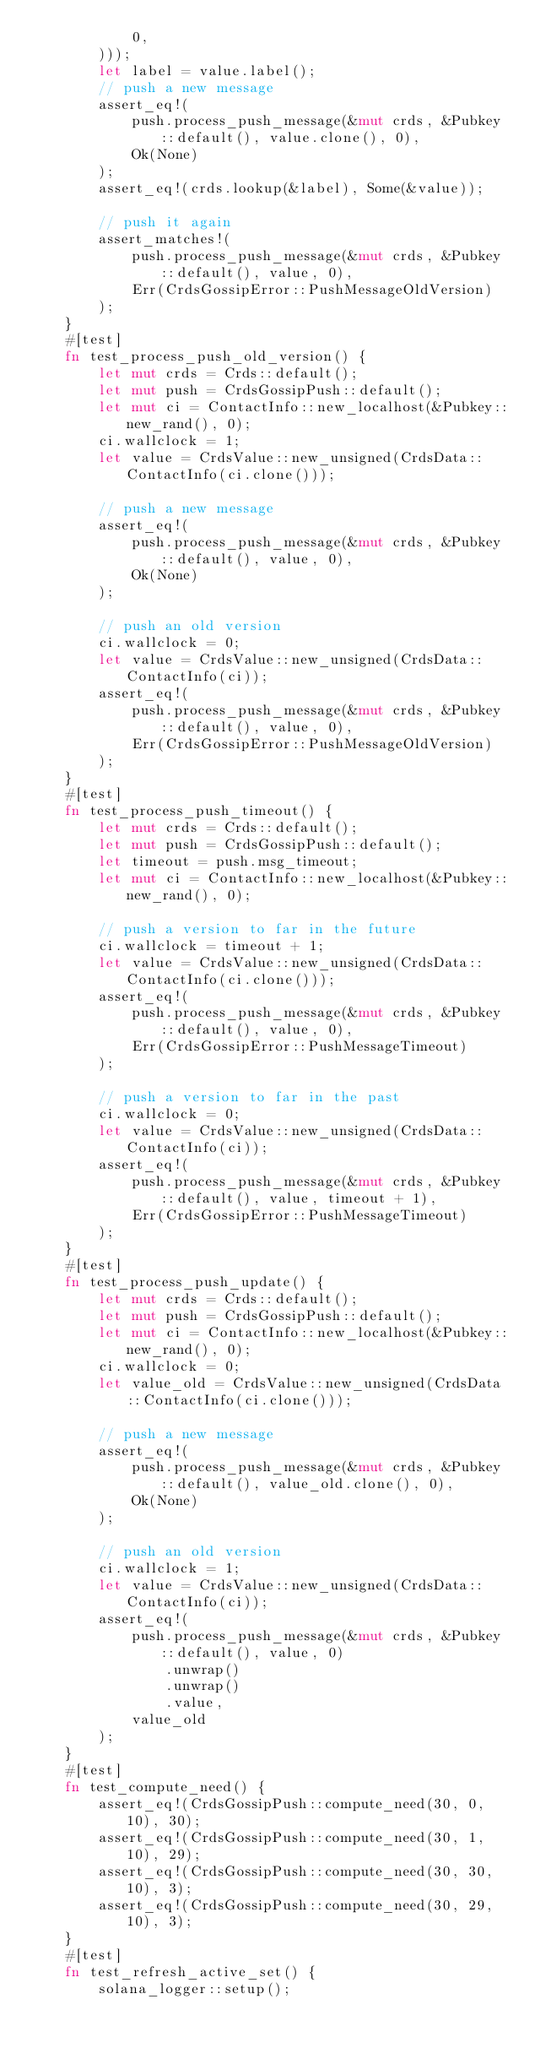<code> <loc_0><loc_0><loc_500><loc_500><_Rust_>            0,
        )));
        let label = value.label();
        // push a new message
        assert_eq!(
            push.process_push_message(&mut crds, &Pubkey::default(), value.clone(), 0),
            Ok(None)
        );
        assert_eq!(crds.lookup(&label), Some(&value));

        // push it again
        assert_matches!(
            push.process_push_message(&mut crds, &Pubkey::default(), value, 0),
            Err(CrdsGossipError::PushMessageOldVersion)
        );
    }
    #[test]
    fn test_process_push_old_version() {
        let mut crds = Crds::default();
        let mut push = CrdsGossipPush::default();
        let mut ci = ContactInfo::new_localhost(&Pubkey::new_rand(), 0);
        ci.wallclock = 1;
        let value = CrdsValue::new_unsigned(CrdsData::ContactInfo(ci.clone()));

        // push a new message
        assert_eq!(
            push.process_push_message(&mut crds, &Pubkey::default(), value, 0),
            Ok(None)
        );

        // push an old version
        ci.wallclock = 0;
        let value = CrdsValue::new_unsigned(CrdsData::ContactInfo(ci));
        assert_eq!(
            push.process_push_message(&mut crds, &Pubkey::default(), value, 0),
            Err(CrdsGossipError::PushMessageOldVersion)
        );
    }
    #[test]
    fn test_process_push_timeout() {
        let mut crds = Crds::default();
        let mut push = CrdsGossipPush::default();
        let timeout = push.msg_timeout;
        let mut ci = ContactInfo::new_localhost(&Pubkey::new_rand(), 0);

        // push a version to far in the future
        ci.wallclock = timeout + 1;
        let value = CrdsValue::new_unsigned(CrdsData::ContactInfo(ci.clone()));
        assert_eq!(
            push.process_push_message(&mut crds, &Pubkey::default(), value, 0),
            Err(CrdsGossipError::PushMessageTimeout)
        );

        // push a version to far in the past
        ci.wallclock = 0;
        let value = CrdsValue::new_unsigned(CrdsData::ContactInfo(ci));
        assert_eq!(
            push.process_push_message(&mut crds, &Pubkey::default(), value, timeout + 1),
            Err(CrdsGossipError::PushMessageTimeout)
        );
    }
    #[test]
    fn test_process_push_update() {
        let mut crds = Crds::default();
        let mut push = CrdsGossipPush::default();
        let mut ci = ContactInfo::new_localhost(&Pubkey::new_rand(), 0);
        ci.wallclock = 0;
        let value_old = CrdsValue::new_unsigned(CrdsData::ContactInfo(ci.clone()));

        // push a new message
        assert_eq!(
            push.process_push_message(&mut crds, &Pubkey::default(), value_old.clone(), 0),
            Ok(None)
        );

        // push an old version
        ci.wallclock = 1;
        let value = CrdsValue::new_unsigned(CrdsData::ContactInfo(ci));
        assert_eq!(
            push.process_push_message(&mut crds, &Pubkey::default(), value, 0)
                .unwrap()
                .unwrap()
                .value,
            value_old
        );
    }
    #[test]
    fn test_compute_need() {
        assert_eq!(CrdsGossipPush::compute_need(30, 0, 10), 30);
        assert_eq!(CrdsGossipPush::compute_need(30, 1, 10), 29);
        assert_eq!(CrdsGossipPush::compute_need(30, 30, 10), 3);
        assert_eq!(CrdsGossipPush::compute_need(30, 29, 10), 3);
    }
    #[test]
    fn test_refresh_active_set() {
        solana_logger::setup();</code> 